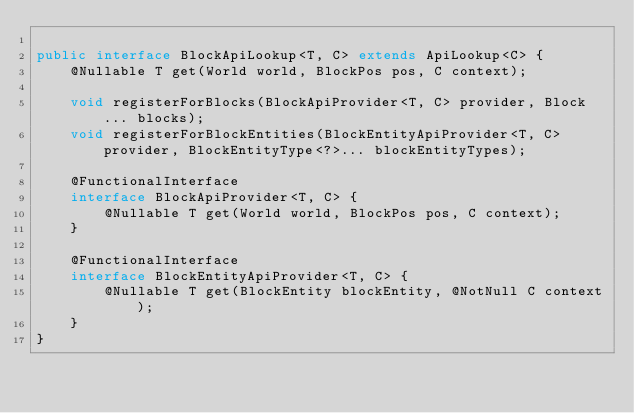<code> <loc_0><loc_0><loc_500><loc_500><_Java_>
public interface BlockApiLookup<T, C> extends ApiLookup<C> {
    @Nullable T get(World world, BlockPos pos, C context);

    void registerForBlocks(BlockApiProvider<T, C> provider, Block... blocks);
    void registerForBlockEntities(BlockEntityApiProvider<T, C> provider, BlockEntityType<?>... blockEntityTypes);

    @FunctionalInterface
    interface BlockApiProvider<T, C> {
        @Nullable T get(World world, BlockPos pos, C context);
    }

    @FunctionalInterface
    interface BlockEntityApiProvider<T, C> {
        @Nullable T get(BlockEntity blockEntity, @NotNull C context);
    }
}
</code> 